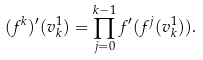<formula> <loc_0><loc_0><loc_500><loc_500>( f ^ { k } ) ^ { \prime } ( v _ { k } ^ { 1 } ) = \prod _ { j = 0 } ^ { k - 1 } f ^ { \prime } ( f ^ { j } ( v _ { k } ^ { 1 } ) ) .</formula> 